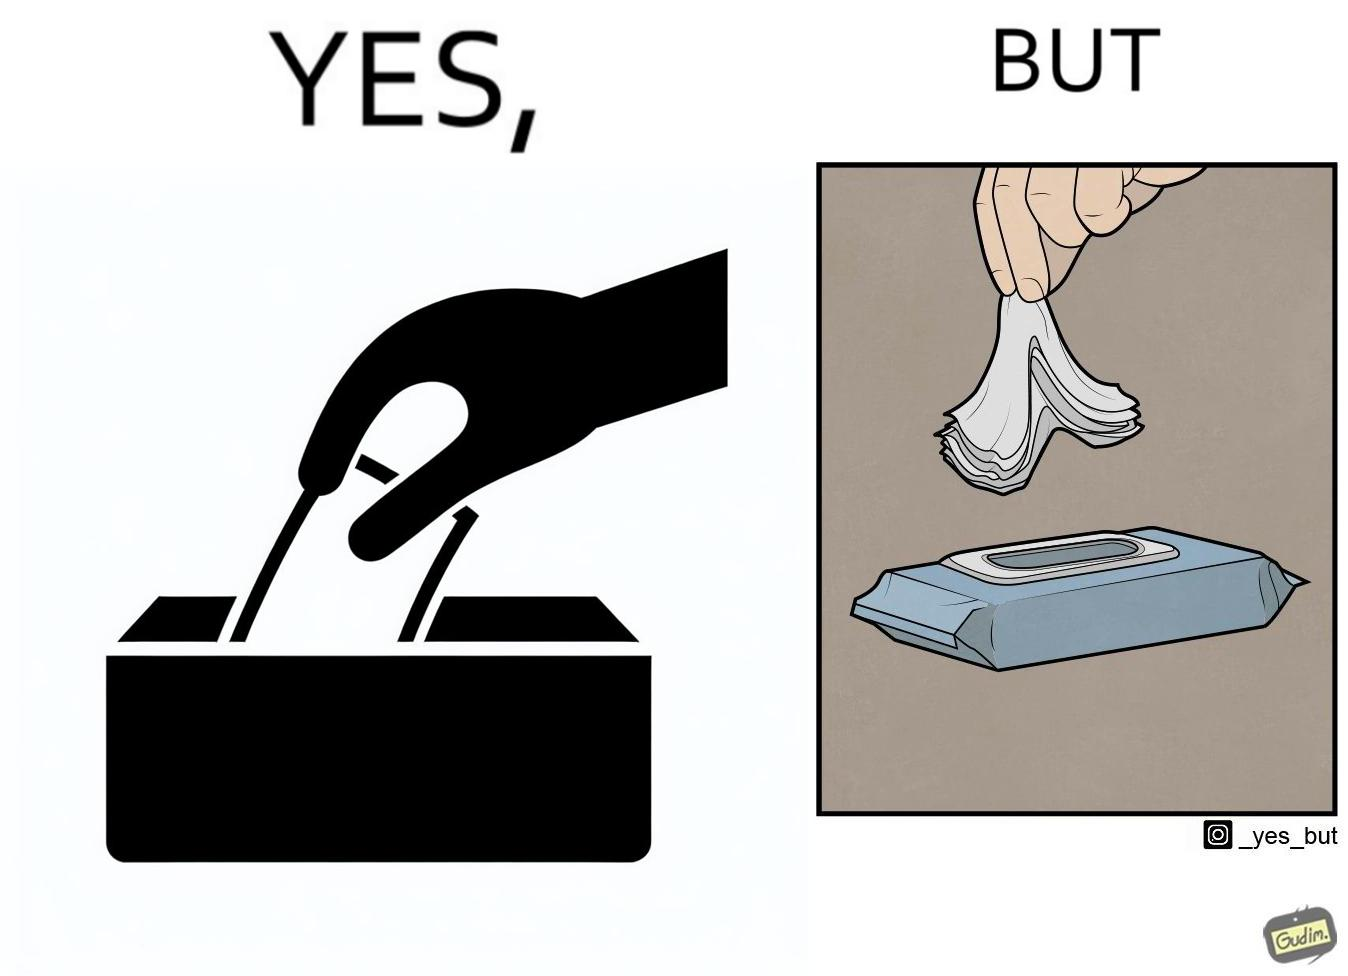Provide a description of this image. The image is ironic, because even when there is a need of only one napkin but the napkins are so tightly packed that more than one napkin gets out sticked together 